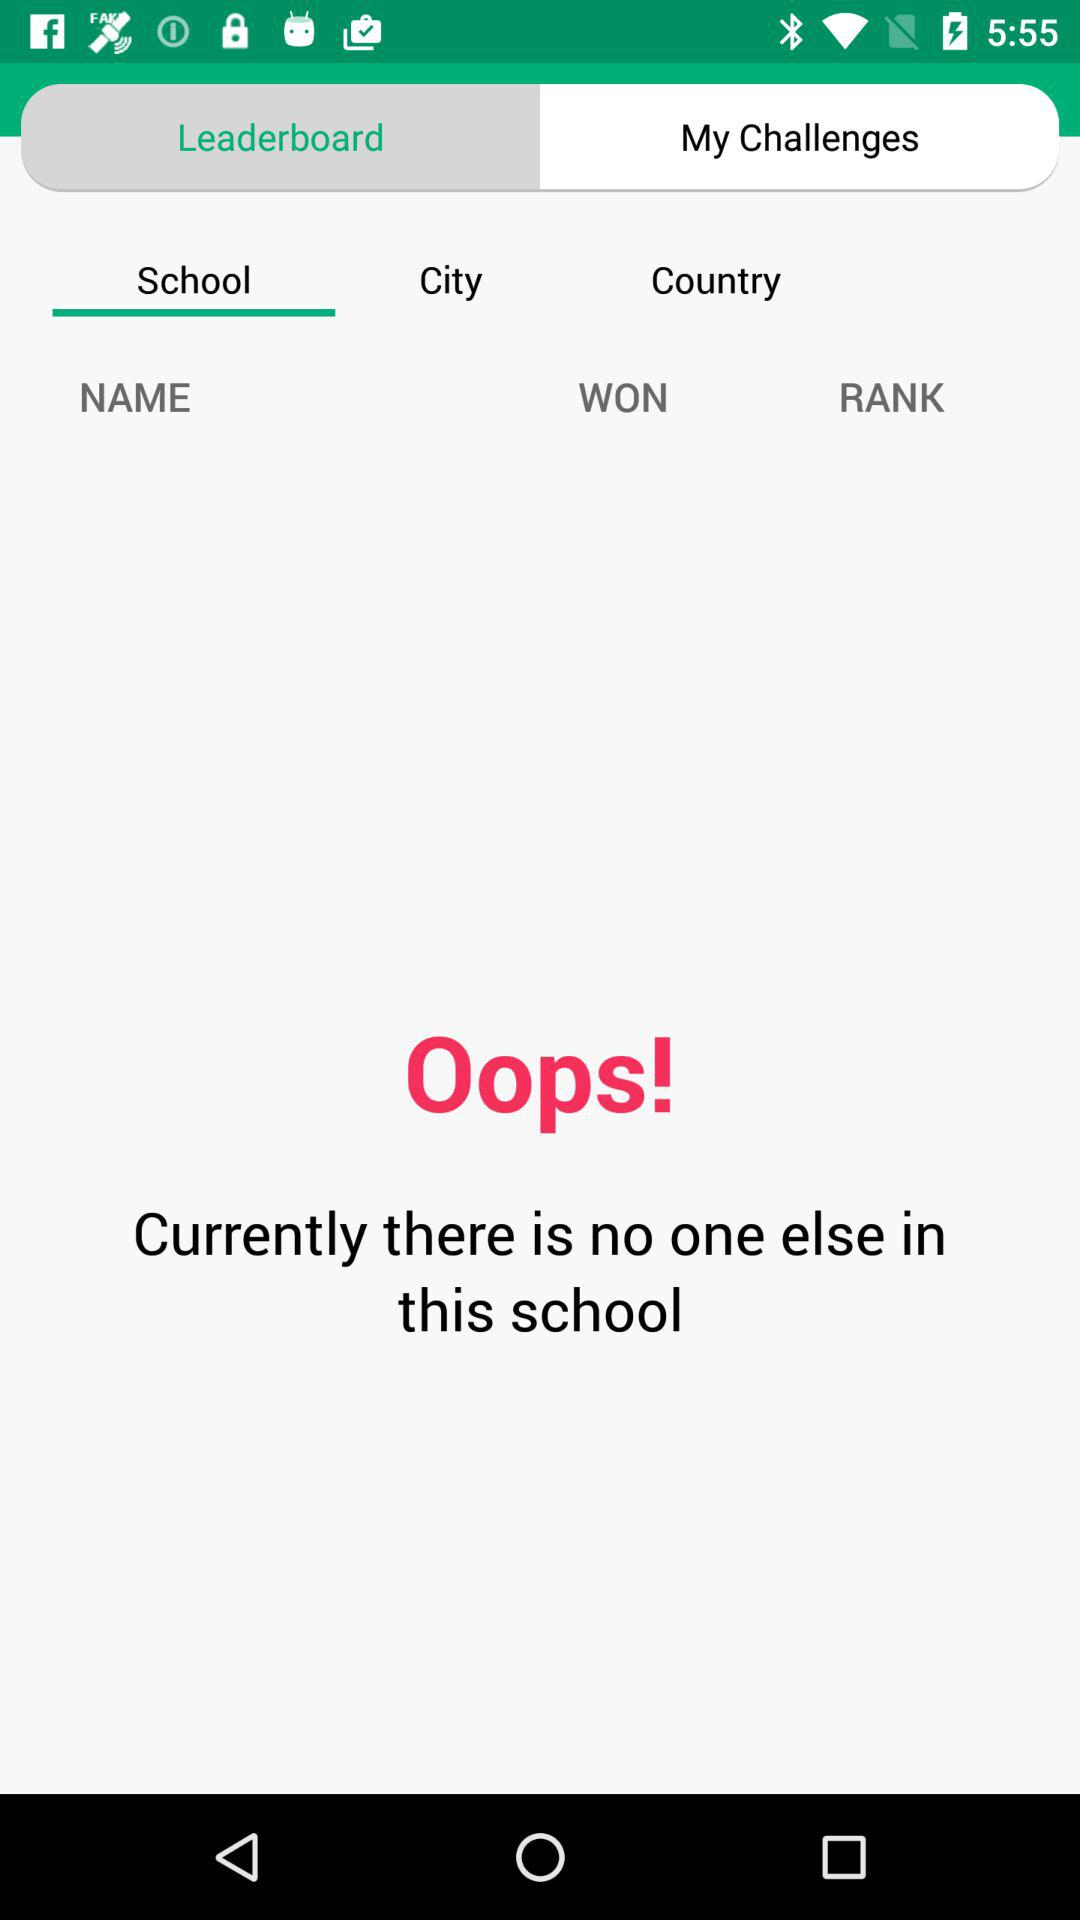What is the selected tab? The selected tab is "School". 